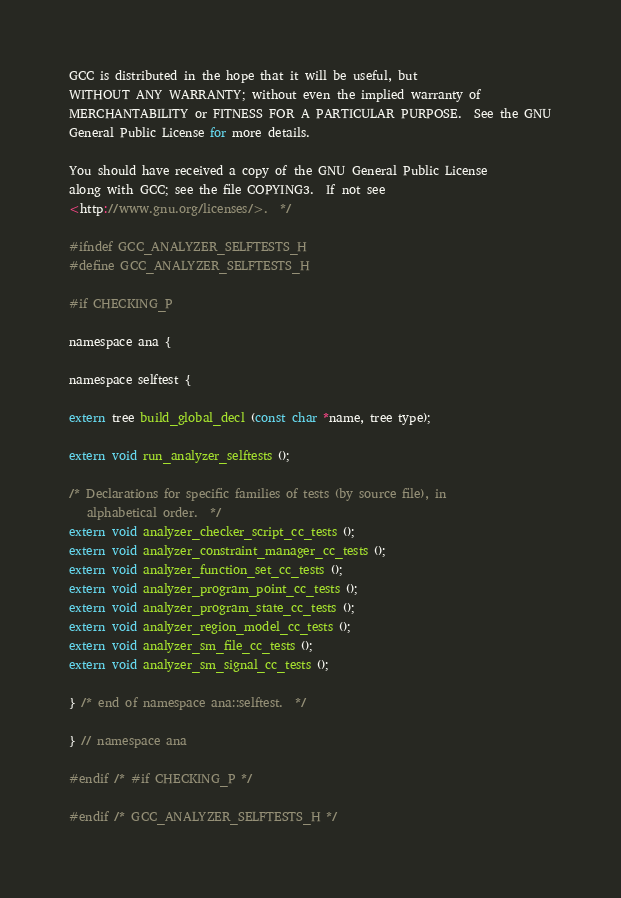<code> <loc_0><loc_0><loc_500><loc_500><_C_>GCC is distributed in the hope that it will be useful, but
WITHOUT ANY WARRANTY; without even the implied warranty of
MERCHANTABILITY or FITNESS FOR A PARTICULAR PURPOSE.  See the GNU
General Public License for more details.

You should have received a copy of the GNU General Public License
along with GCC; see the file COPYING3.  If not see
<http://www.gnu.org/licenses/>.  */

#ifndef GCC_ANALYZER_SELFTESTS_H
#define GCC_ANALYZER_SELFTESTS_H

#if CHECKING_P

namespace ana {

namespace selftest {

extern tree build_global_decl (const char *name, tree type);

extern void run_analyzer_selftests ();

/* Declarations for specific families of tests (by source file), in
   alphabetical order.  */
extern void analyzer_checker_script_cc_tests ();
extern void analyzer_constraint_manager_cc_tests ();
extern void analyzer_function_set_cc_tests ();
extern void analyzer_program_point_cc_tests ();
extern void analyzer_program_state_cc_tests ();
extern void analyzer_region_model_cc_tests ();
extern void analyzer_sm_file_cc_tests ();
extern void analyzer_sm_signal_cc_tests ();

} /* end of namespace ana::selftest.  */

} // namespace ana

#endif /* #if CHECKING_P */

#endif /* GCC_ANALYZER_SELFTESTS_H */
</code> 